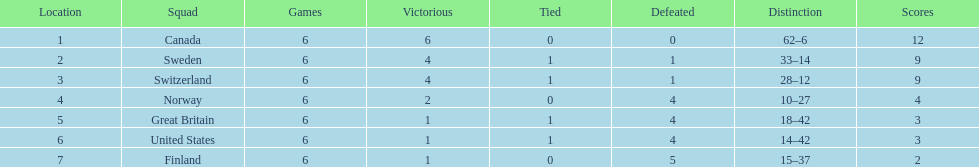I'm looking to parse the entire table for insights. Could you assist me with that? {'header': ['Location', 'Squad', 'Games', 'Victorious', 'Tied', 'Defeated', 'Distinction', 'Scores'], 'rows': [['1', 'Canada', '6', '6', '0', '0', '62–6', '12'], ['2', 'Sweden', '6', '4', '1', '1', '33–14', '9'], ['3', 'Switzerland', '6', '4', '1', '1', '28–12', '9'], ['4', 'Norway', '6', '2', '0', '4', '10–27', '4'], ['5', 'Great Britain', '6', '1', '1', '4', '18–42', '3'], ['6', 'United States', '6', '1', '1', '4', '14–42', '3'], ['7', 'Finland', '6', '1', '0', '5', '15–37', '2']]} What was the number of points won by great britain? 3. 